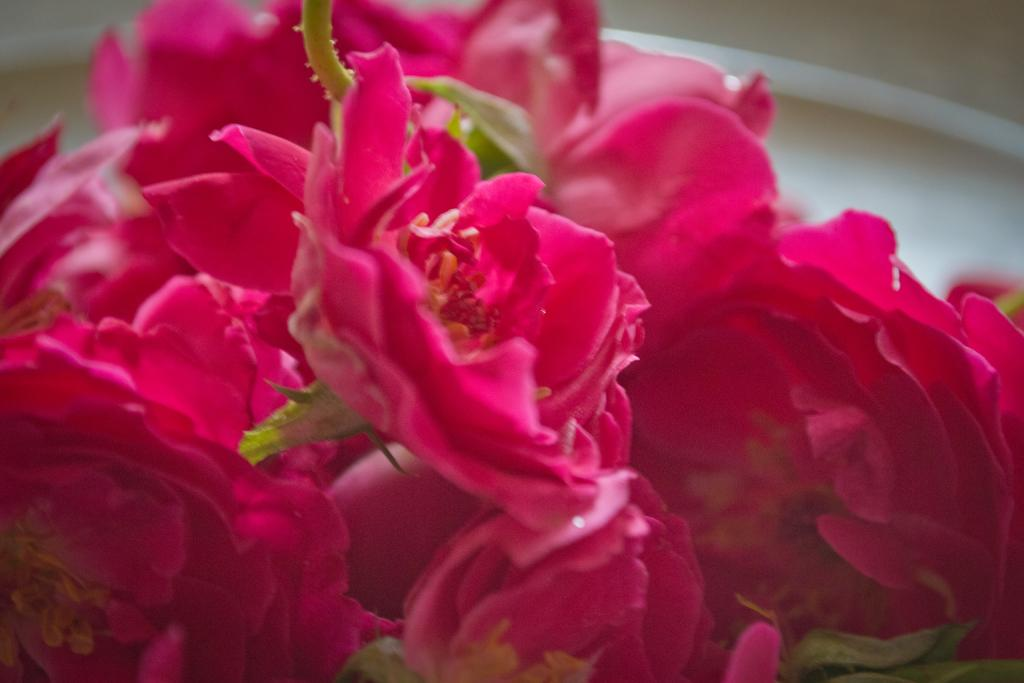What type of flowers can be seen in the image? There are pink color flowers in the image. What type of feather can be seen on the match in the image? There is no match or feather present in the image; it only features pink color flowers. 